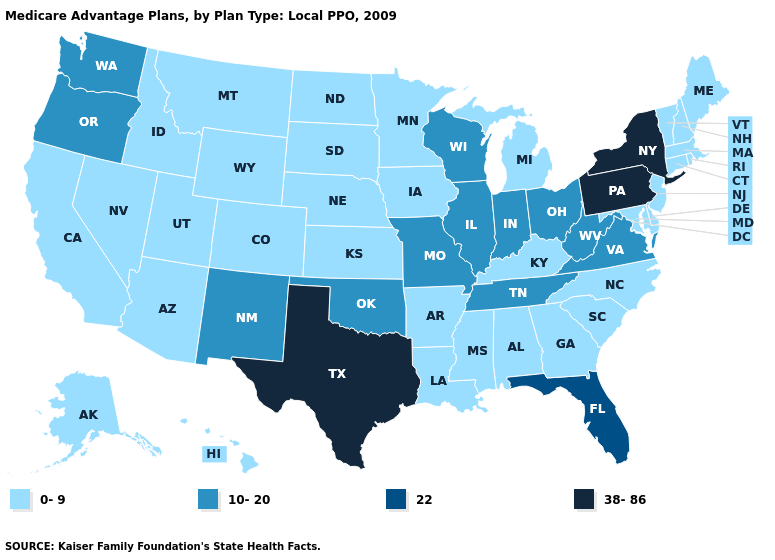Is the legend a continuous bar?
Give a very brief answer. No. What is the value of Indiana?
Write a very short answer. 10-20. What is the value of Alaska?
Be succinct. 0-9. Which states have the lowest value in the USA?
Write a very short answer. Alaska, Alabama, Arkansas, Arizona, California, Colorado, Connecticut, Delaware, Georgia, Hawaii, Iowa, Idaho, Kansas, Kentucky, Louisiana, Massachusetts, Maryland, Maine, Michigan, Minnesota, Mississippi, Montana, North Carolina, North Dakota, Nebraska, New Hampshire, New Jersey, Nevada, Rhode Island, South Carolina, South Dakota, Utah, Vermont, Wyoming. Name the states that have a value in the range 0-9?
Be succinct. Alaska, Alabama, Arkansas, Arizona, California, Colorado, Connecticut, Delaware, Georgia, Hawaii, Iowa, Idaho, Kansas, Kentucky, Louisiana, Massachusetts, Maryland, Maine, Michigan, Minnesota, Mississippi, Montana, North Carolina, North Dakota, Nebraska, New Hampshire, New Jersey, Nevada, Rhode Island, South Carolina, South Dakota, Utah, Vermont, Wyoming. Name the states that have a value in the range 22?
Short answer required. Florida. Name the states that have a value in the range 38-86?
Answer briefly. New York, Pennsylvania, Texas. What is the lowest value in the South?
Keep it brief. 0-9. Which states have the highest value in the USA?
Give a very brief answer. New York, Pennsylvania, Texas. Name the states that have a value in the range 0-9?
Quick response, please. Alaska, Alabama, Arkansas, Arizona, California, Colorado, Connecticut, Delaware, Georgia, Hawaii, Iowa, Idaho, Kansas, Kentucky, Louisiana, Massachusetts, Maryland, Maine, Michigan, Minnesota, Mississippi, Montana, North Carolina, North Dakota, Nebraska, New Hampshire, New Jersey, Nevada, Rhode Island, South Carolina, South Dakota, Utah, Vermont, Wyoming. Name the states that have a value in the range 0-9?
Give a very brief answer. Alaska, Alabama, Arkansas, Arizona, California, Colorado, Connecticut, Delaware, Georgia, Hawaii, Iowa, Idaho, Kansas, Kentucky, Louisiana, Massachusetts, Maryland, Maine, Michigan, Minnesota, Mississippi, Montana, North Carolina, North Dakota, Nebraska, New Hampshire, New Jersey, Nevada, Rhode Island, South Carolina, South Dakota, Utah, Vermont, Wyoming. Does Tennessee have the lowest value in the South?
Quick response, please. No. What is the highest value in states that border Georgia?
Write a very short answer. 22. What is the highest value in states that border Montana?
Keep it brief. 0-9. Among the states that border Alabama , which have the lowest value?
Quick response, please. Georgia, Mississippi. 